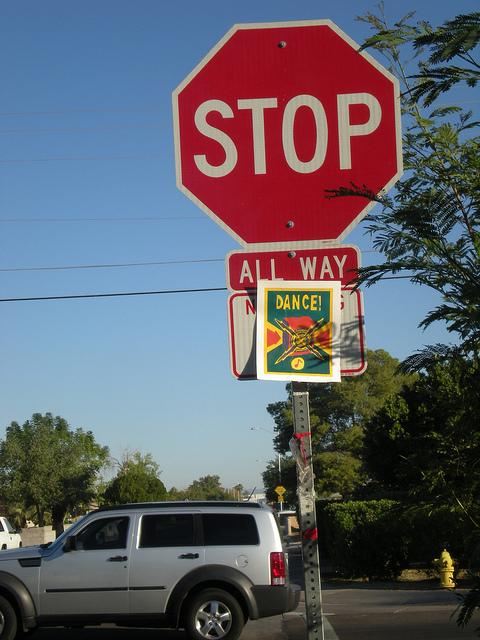How many people must stop at the intersection? Please explain your reasoning. four. All four ways should stop at the intersection. 